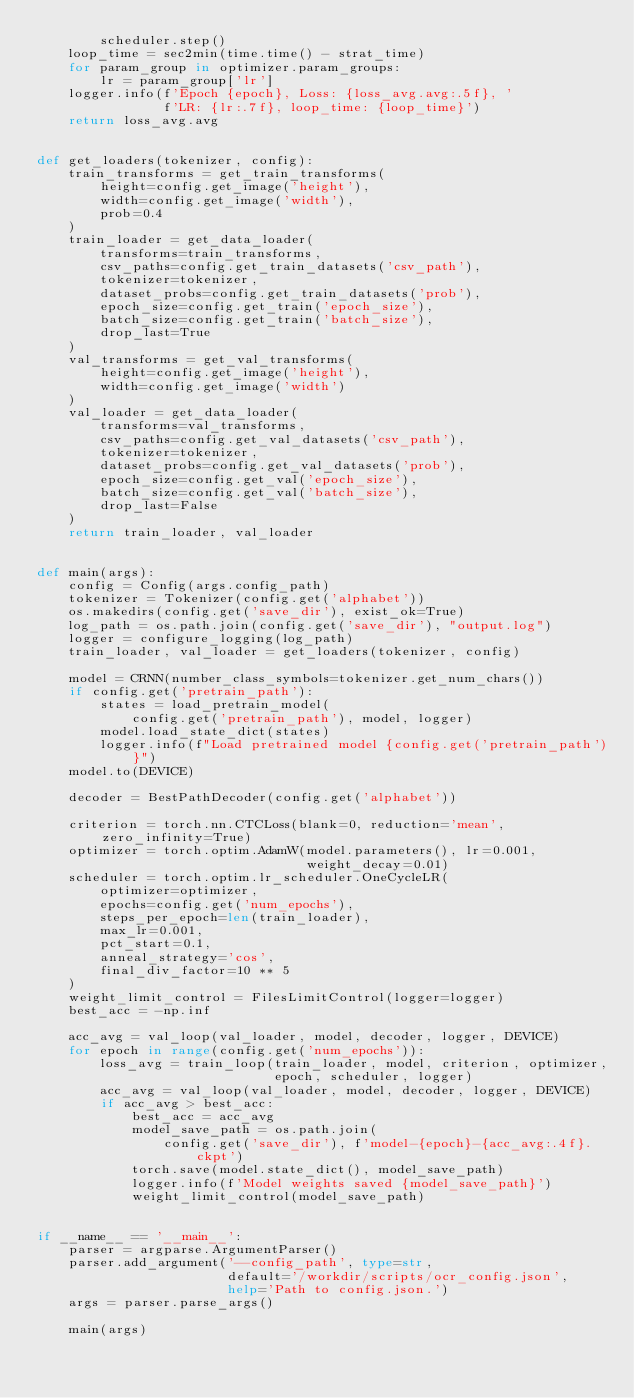Convert code to text. <code><loc_0><loc_0><loc_500><loc_500><_Python_>        scheduler.step()
    loop_time = sec2min(time.time() - strat_time)
    for param_group in optimizer.param_groups:
        lr = param_group['lr']
    logger.info(f'Epoch {epoch}, Loss: {loss_avg.avg:.5f}, '
                f'LR: {lr:.7f}, loop_time: {loop_time}')
    return loss_avg.avg


def get_loaders(tokenizer, config):
    train_transforms = get_train_transforms(
        height=config.get_image('height'),
        width=config.get_image('width'),
        prob=0.4
    )
    train_loader = get_data_loader(
        transforms=train_transforms,
        csv_paths=config.get_train_datasets('csv_path'),
        tokenizer=tokenizer,
        dataset_probs=config.get_train_datasets('prob'),
        epoch_size=config.get_train('epoch_size'),
        batch_size=config.get_train('batch_size'),
        drop_last=True
    )
    val_transforms = get_val_transforms(
        height=config.get_image('height'),
        width=config.get_image('width')
    )
    val_loader = get_data_loader(
        transforms=val_transforms,
        csv_paths=config.get_val_datasets('csv_path'),
        tokenizer=tokenizer,
        dataset_probs=config.get_val_datasets('prob'),
        epoch_size=config.get_val('epoch_size'),
        batch_size=config.get_val('batch_size'),
        drop_last=False
    )
    return train_loader, val_loader


def main(args):
    config = Config(args.config_path)
    tokenizer = Tokenizer(config.get('alphabet'))
    os.makedirs(config.get('save_dir'), exist_ok=True)
    log_path = os.path.join(config.get('save_dir'), "output.log")
    logger = configure_logging(log_path)
    train_loader, val_loader = get_loaders(tokenizer, config)

    model = CRNN(number_class_symbols=tokenizer.get_num_chars())
    if config.get('pretrain_path'):
        states = load_pretrain_model(
            config.get('pretrain_path'), model, logger)
        model.load_state_dict(states)
        logger.info(f"Load pretrained model {config.get('pretrain_path')}")
    model.to(DEVICE)

    decoder = BestPathDecoder(config.get('alphabet'))

    criterion = torch.nn.CTCLoss(blank=0, reduction='mean', zero_infinity=True)
    optimizer = torch.optim.AdamW(model.parameters(), lr=0.001,
                                  weight_decay=0.01)
    scheduler = torch.optim.lr_scheduler.OneCycleLR(
        optimizer=optimizer,
        epochs=config.get('num_epochs'),
        steps_per_epoch=len(train_loader),
        max_lr=0.001,
        pct_start=0.1,
        anneal_strategy='cos',
        final_div_factor=10 ** 5
    )
    weight_limit_control = FilesLimitControl(logger=logger)
    best_acc = -np.inf

    acc_avg = val_loop(val_loader, model, decoder, logger, DEVICE)
    for epoch in range(config.get('num_epochs')):
        loss_avg = train_loop(train_loader, model, criterion, optimizer,
                              epoch, scheduler, logger)
        acc_avg = val_loop(val_loader, model, decoder, logger, DEVICE)
        if acc_avg > best_acc:
            best_acc = acc_avg
            model_save_path = os.path.join(
                config.get('save_dir'), f'model-{epoch}-{acc_avg:.4f}.ckpt')
            torch.save(model.state_dict(), model_save_path)
            logger.info(f'Model weights saved {model_save_path}')
            weight_limit_control(model_save_path)


if __name__ == '__main__':
    parser = argparse.ArgumentParser()
    parser.add_argument('--config_path', type=str,
                        default='/workdir/scripts/ocr_config.json',
                        help='Path to config.json.')
    args = parser.parse_args()

    main(args)
</code> 